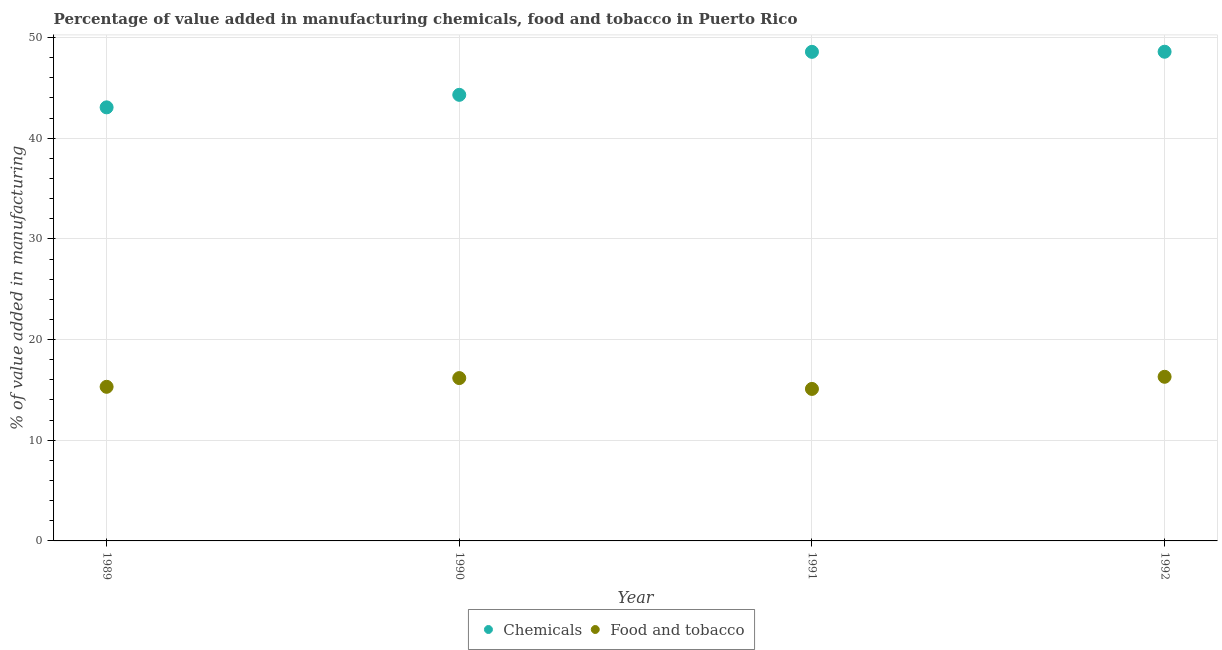What is the value added by  manufacturing chemicals in 1991?
Keep it short and to the point. 48.58. Across all years, what is the maximum value added by manufacturing food and tobacco?
Offer a very short reply. 16.3. Across all years, what is the minimum value added by  manufacturing chemicals?
Your answer should be very brief. 43.07. In which year was the value added by manufacturing food and tobacco maximum?
Your answer should be compact. 1992. In which year was the value added by  manufacturing chemicals minimum?
Offer a very short reply. 1989. What is the total value added by manufacturing food and tobacco in the graph?
Offer a terse response. 62.88. What is the difference between the value added by manufacturing food and tobacco in 1989 and that in 1990?
Make the answer very short. -0.87. What is the difference between the value added by  manufacturing chemicals in 1990 and the value added by manufacturing food and tobacco in 1991?
Your response must be concise. 29.21. What is the average value added by manufacturing food and tobacco per year?
Make the answer very short. 15.72. In the year 1992, what is the difference between the value added by manufacturing food and tobacco and value added by  manufacturing chemicals?
Your answer should be compact. -32.29. In how many years, is the value added by  manufacturing chemicals greater than 38 %?
Your answer should be very brief. 4. What is the ratio of the value added by manufacturing food and tobacco in 1990 to that in 1992?
Make the answer very short. 0.99. Is the value added by  manufacturing chemicals in 1991 less than that in 1992?
Give a very brief answer. Yes. What is the difference between the highest and the second highest value added by  manufacturing chemicals?
Keep it short and to the point. 0.01. What is the difference between the highest and the lowest value added by  manufacturing chemicals?
Your response must be concise. 5.53. Does the value added by  manufacturing chemicals monotonically increase over the years?
Provide a succinct answer. Yes. Is the value added by  manufacturing chemicals strictly greater than the value added by manufacturing food and tobacco over the years?
Make the answer very short. Yes. Is the value added by manufacturing food and tobacco strictly less than the value added by  manufacturing chemicals over the years?
Keep it short and to the point. Yes. How many dotlines are there?
Your answer should be very brief. 2. Does the graph contain any zero values?
Provide a succinct answer. No. Does the graph contain grids?
Give a very brief answer. Yes. How many legend labels are there?
Your answer should be very brief. 2. What is the title of the graph?
Make the answer very short. Percentage of value added in manufacturing chemicals, food and tobacco in Puerto Rico. Does "GDP at market prices" appear as one of the legend labels in the graph?
Offer a very short reply. No. What is the label or title of the X-axis?
Ensure brevity in your answer.  Year. What is the label or title of the Y-axis?
Give a very brief answer. % of value added in manufacturing. What is the % of value added in manufacturing in Chemicals in 1989?
Your response must be concise. 43.07. What is the % of value added in manufacturing in Food and tobacco in 1989?
Offer a terse response. 15.31. What is the % of value added in manufacturing of Chemicals in 1990?
Offer a very short reply. 44.31. What is the % of value added in manufacturing of Food and tobacco in 1990?
Your answer should be compact. 16.17. What is the % of value added in manufacturing in Chemicals in 1991?
Offer a very short reply. 48.58. What is the % of value added in manufacturing of Food and tobacco in 1991?
Ensure brevity in your answer.  15.1. What is the % of value added in manufacturing in Chemicals in 1992?
Offer a very short reply. 48.59. What is the % of value added in manufacturing of Food and tobacco in 1992?
Your answer should be compact. 16.3. Across all years, what is the maximum % of value added in manufacturing of Chemicals?
Ensure brevity in your answer.  48.59. Across all years, what is the maximum % of value added in manufacturing of Food and tobacco?
Your answer should be very brief. 16.3. Across all years, what is the minimum % of value added in manufacturing of Chemicals?
Offer a terse response. 43.07. Across all years, what is the minimum % of value added in manufacturing in Food and tobacco?
Your response must be concise. 15.1. What is the total % of value added in manufacturing of Chemicals in the graph?
Offer a terse response. 184.54. What is the total % of value added in manufacturing of Food and tobacco in the graph?
Ensure brevity in your answer.  62.88. What is the difference between the % of value added in manufacturing in Chemicals in 1989 and that in 1990?
Offer a terse response. -1.24. What is the difference between the % of value added in manufacturing of Food and tobacco in 1989 and that in 1990?
Provide a succinct answer. -0.87. What is the difference between the % of value added in manufacturing in Chemicals in 1989 and that in 1991?
Provide a short and direct response. -5.51. What is the difference between the % of value added in manufacturing of Food and tobacco in 1989 and that in 1991?
Your answer should be very brief. 0.21. What is the difference between the % of value added in manufacturing in Chemicals in 1989 and that in 1992?
Offer a very short reply. -5.53. What is the difference between the % of value added in manufacturing in Food and tobacco in 1989 and that in 1992?
Offer a terse response. -1. What is the difference between the % of value added in manufacturing of Chemicals in 1990 and that in 1991?
Your response must be concise. -4.27. What is the difference between the % of value added in manufacturing of Food and tobacco in 1990 and that in 1991?
Your response must be concise. 1.08. What is the difference between the % of value added in manufacturing of Chemicals in 1990 and that in 1992?
Make the answer very short. -4.28. What is the difference between the % of value added in manufacturing in Food and tobacco in 1990 and that in 1992?
Keep it short and to the point. -0.13. What is the difference between the % of value added in manufacturing of Chemicals in 1991 and that in 1992?
Provide a succinct answer. -0.01. What is the difference between the % of value added in manufacturing in Food and tobacco in 1991 and that in 1992?
Provide a succinct answer. -1.21. What is the difference between the % of value added in manufacturing in Chemicals in 1989 and the % of value added in manufacturing in Food and tobacco in 1990?
Ensure brevity in your answer.  26.89. What is the difference between the % of value added in manufacturing in Chemicals in 1989 and the % of value added in manufacturing in Food and tobacco in 1991?
Offer a very short reply. 27.97. What is the difference between the % of value added in manufacturing of Chemicals in 1989 and the % of value added in manufacturing of Food and tobacco in 1992?
Your answer should be very brief. 26.76. What is the difference between the % of value added in manufacturing in Chemicals in 1990 and the % of value added in manufacturing in Food and tobacco in 1991?
Offer a terse response. 29.21. What is the difference between the % of value added in manufacturing in Chemicals in 1990 and the % of value added in manufacturing in Food and tobacco in 1992?
Your response must be concise. 28.01. What is the difference between the % of value added in manufacturing in Chemicals in 1991 and the % of value added in manufacturing in Food and tobacco in 1992?
Make the answer very short. 32.28. What is the average % of value added in manufacturing of Chemicals per year?
Your answer should be compact. 46.14. What is the average % of value added in manufacturing of Food and tobacco per year?
Provide a short and direct response. 15.72. In the year 1989, what is the difference between the % of value added in manufacturing in Chemicals and % of value added in manufacturing in Food and tobacco?
Your answer should be very brief. 27.76. In the year 1990, what is the difference between the % of value added in manufacturing of Chemicals and % of value added in manufacturing of Food and tobacco?
Your answer should be compact. 28.13. In the year 1991, what is the difference between the % of value added in manufacturing of Chemicals and % of value added in manufacturing of Food and tobacco?
Your answer should be compact. 33.48. In the year 1992, what is the difference between the % of value added in manufacturing of Chemicals and % of value added in manufacturing of Food and tobacco?
Your answer should be very brief. 32.29. What is the ratio of the % of value added in manufacturing of Chemicals in 1989 to that in 1990?
Your answer should be very brief. 0.97. What is the ratio of the % of value added in manufacturing in Food and tobacco in 1989 to that in 1990?
Make the answer very short. 0.95. What is the ratio of the % of value added in manufacturing in Chemicals in 1989 to that in 1991?
Offer a very short reply. 0.89. What is the ratio of the % of value added in manufacturing in Food and tobacco in 1989 to that in 1991?
Give a very brief answer. 1.01. What is the ratio of the % of value added in manufacturing of Chemicals in 1989 to that in 1992?
Your answer should be very brief. 0.89. What is the ratio of the % of value added in manufacturing in Food and tobacco in 1989 to that in 1992?
Your answer should be very brief. 0.94. What is the ratio of the % of value added in manufacturing of Chemicals in 1990 to that in 1991?
Offer a terse response. 0.91. What is the ratio of the % of value added in manufacturing in Food and tobacco in 1990 to that in 1991?
Your response must be concise. 1.07. What is the ratio of the % of value added in manufacturing of Chemicals in 1990 to that in 1992?
Offer a very short reply. 0.91. What is the ratio of the % of value added in manufacturing in Food and tobacco in 1991 to that in 1992?
Offer a terse response. 0.93. What is the difference between the highest and the second highest % of value added in manufacturing in Chemicals?
Provide a succinct answer. 0.01. What is the difference between the highest and the second highest % of value added in manufacturing of Food and tobacco?
Your answer should be very brief. 0.13. What is the difference between the highest and the lowest % of value added in manufacturing in Chemicals?
Your response must be concise. 5.53. What is the difference between the highest and the lowest % of value added in manufacturing in Food and tobacco?
Provide a succinct answer. 1.21. 